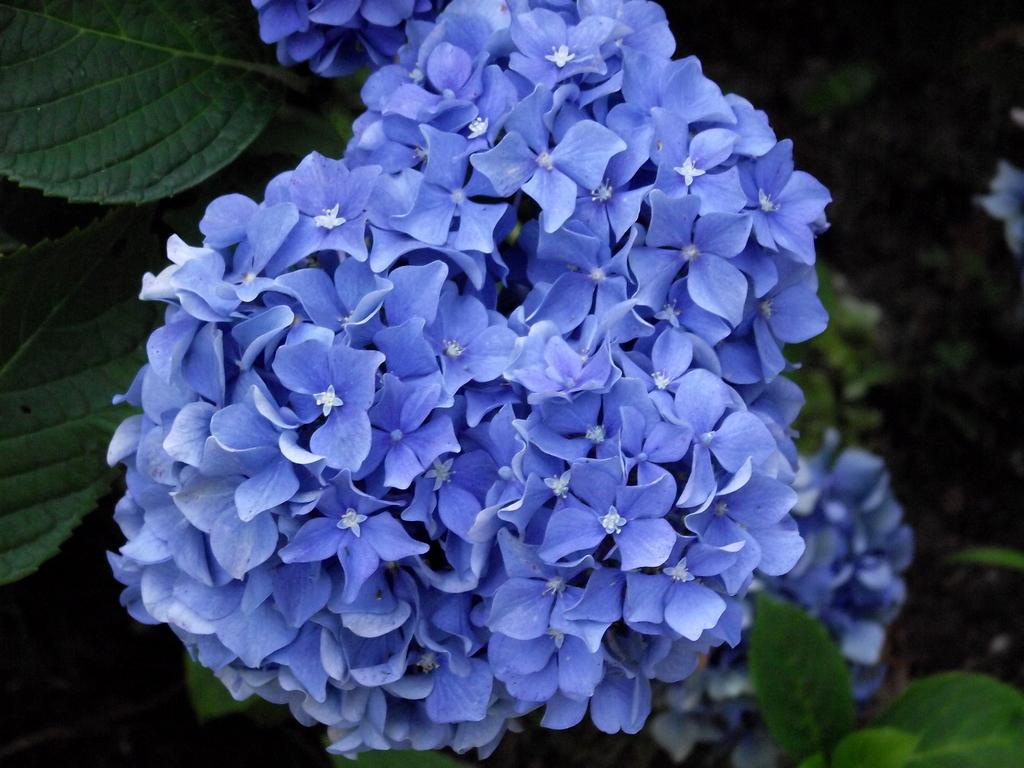What is the main subject of the image? The main subject of the image is a bunch of flowers. Are there any other plant-related elements in the image? Yes, there are leaves in the image. How many pizzas are visible in the image? There are no pizzas present in the image; it features a bunch of flowers and leaves. What is the position of the moon in the image? There is no moon present in the image. 